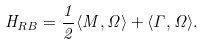Convert formula to latex. <formula><loc_0><loc_0><loc_500><loc_500>H _ { R B } = \frac { 1 } { 2 } \langle M , \Omega \rangle + \langle \Gamma , \Omega \rangle .</formula> 